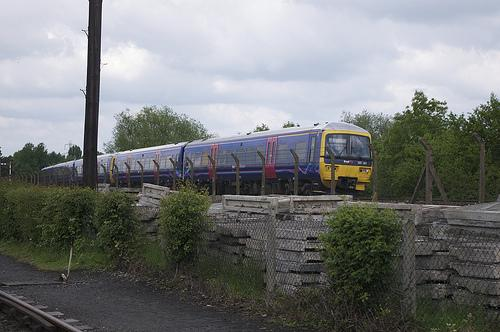Briefly describe the color scheme of the train captured in the image. The train features a bright yellow front, blue body, and red doors with windows. Mention the most prominent features of the train in the image. The train has a distinct yellow front, red doors with windows, and is blue in color. Its windshield has a single wiper. Identify the plants and trees visible in the picture. There are several green bushes by a wall and trees with green leaves in the background. Explain the setting in which the train is present. The train is situated along a track with a metal rail, next to dirt and surrounded by a metal and wood fence, with green bushes and trees nearby. Talk about the things present near the train tracks. There are wooden pallets, concrete blocks, a tall black pole, and a metal rail of the train track near the train tracks. List the types of fences present in the image. In the image, there is a metal chain link fence, a wood and metal fence along the train tracks, and a black chain fence in front of pallets. Explain what the sky looks like in the image. The sky has big, fluffy gray clouds covering a large portion of it. Zoom in on the train's windshield area and tell the details you see. The train's windshield is bordered by windows and has a single windshield wiper mounted on it. Describe in simple terms the photograph's subject and surroundings. The picture shows a train with a yellow front and red doors on a track, surrounded by fences, green plants, and trees under a cloudy sky. Provide a brief overview of the scene captured in the image. A colorful train is parked on the tracks, surrounded by a chain link fence, green bushes, and trees, while fluffy gray clouds loom in the sky. 